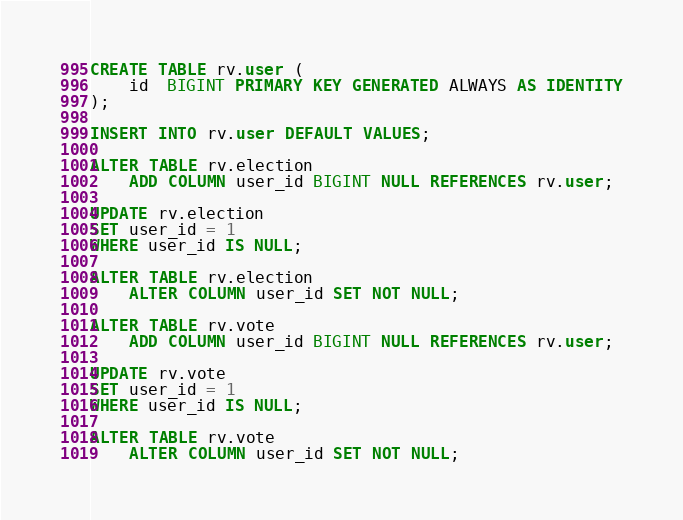Convert code to text. <code><loc_0><loc_0><loc_500><loc_500><_SQL_>CREATE TABLE rv.user (
    id  BIGINT PRIMARY KEY GENERATED ALWAYS AS IDENTITY
);

INSERT INTO rv.user DEFAULT VALUES;

ALTER TABLE rv.election
    ADD COLUMN user_id BIGINT NULL REFERENCES rv.user;

UPDATE rv.election
SET user_id = 1
WHERE user_id IS NULL;

ALTER TABLE rv.election
    ALTER COLUMN user_id SET NOT NULL;

ALTER TABLE rv.vote
    ADD COLUMN user_id BIGINT NULL REFERENCES rv.user;

UPDATE rv.vote
SET user_id = 1
WHERE user_id IS NULL;

ALTER TABLE rv.vote
    ALTER COLUMN user_id SET NOT NULL;
</code> 